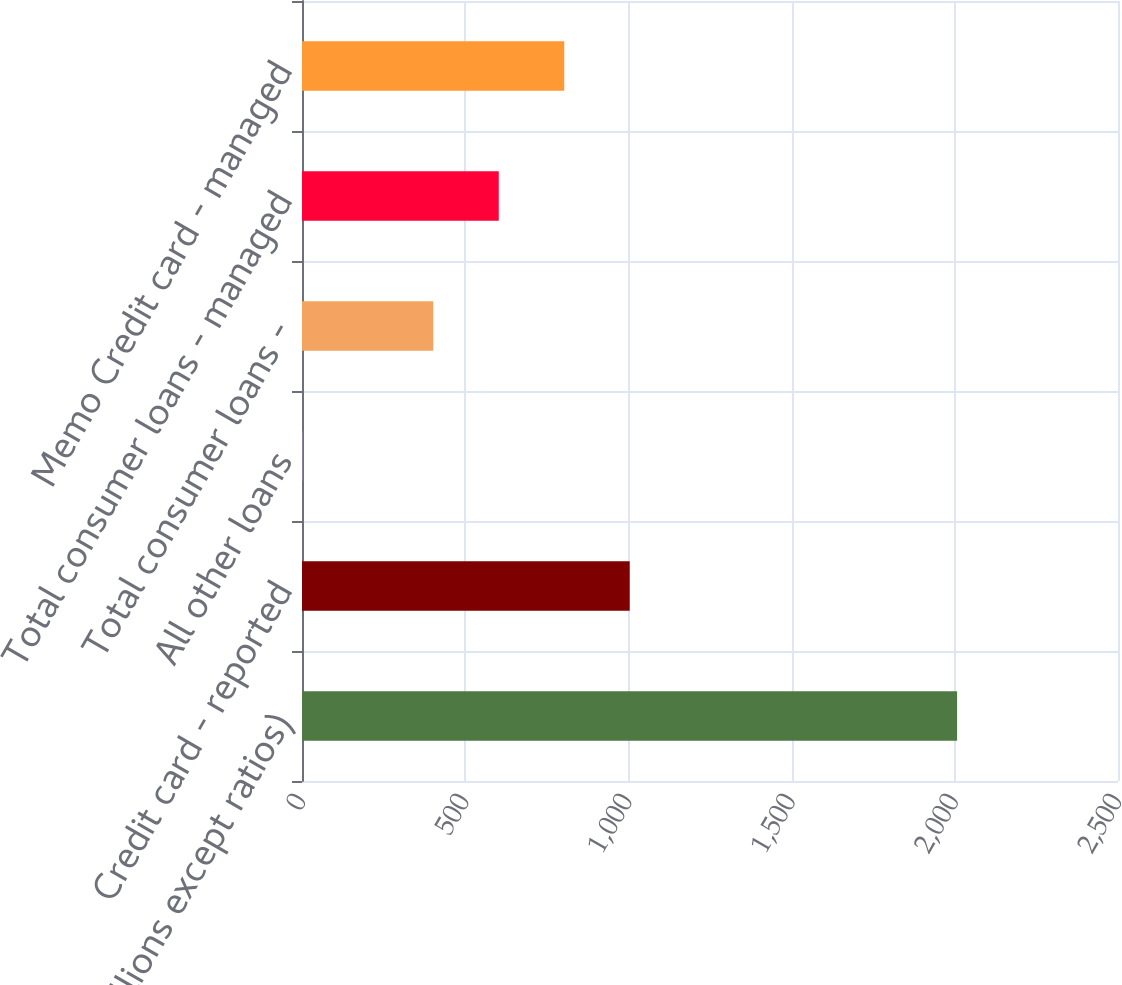Convert chart. <chart><loc_0><loc_0><loc_500><loc_500><bar_chart><fcel>(in millions except ratios)<fcel>Credit card - reported<fcel>All other loans<fcel>Total consumer loans -<fcel>Total consumer loans - managed<fcel>Memo Credit card - managed<nl><fcel>2007<fcel>1004.01<fcel>1.01<fcel>402.21<fcel>602.81<fcel>803.41<nl></chart> 